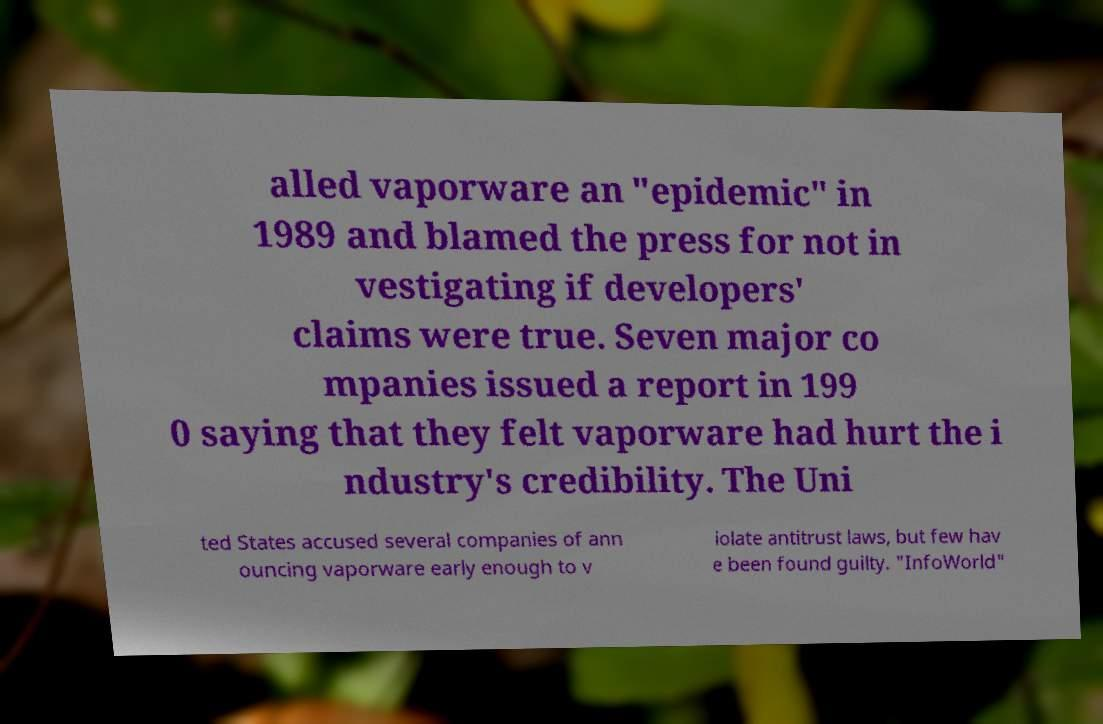Can you accurately transcribe the text from the provided image for me? alled vaporware an "epidemic" in 1989 and blamed the press for not in vestigating if developers' claims were true. Seven major co mpanies issued a report in 199 0 saying that they felt vaporware had hurt the i ndustry's credibility. The Uni ted States accused several companies of ann ouncing vaporware early enough to v iolate antitrust laws, but few hav e been found guilty. "InfoWorld" 